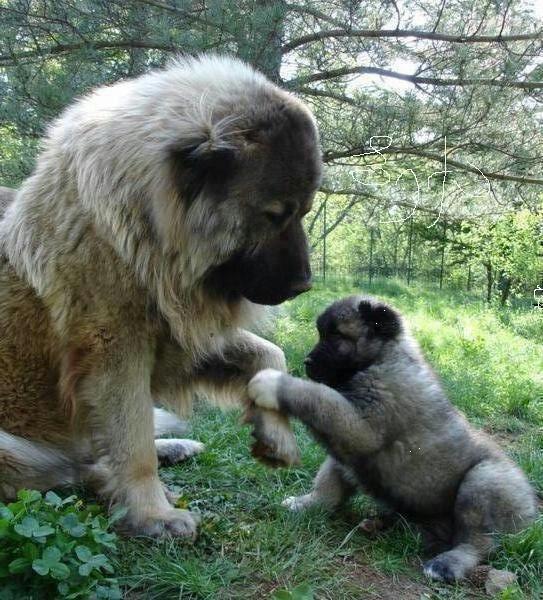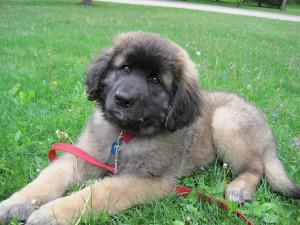The first image is the image on the left, the second image is the image on the right. Evaluate the accuracy of this statement regarding the images: "There is one dog tongue in the image on the left.". Is it true? Answer yes or no. No. 